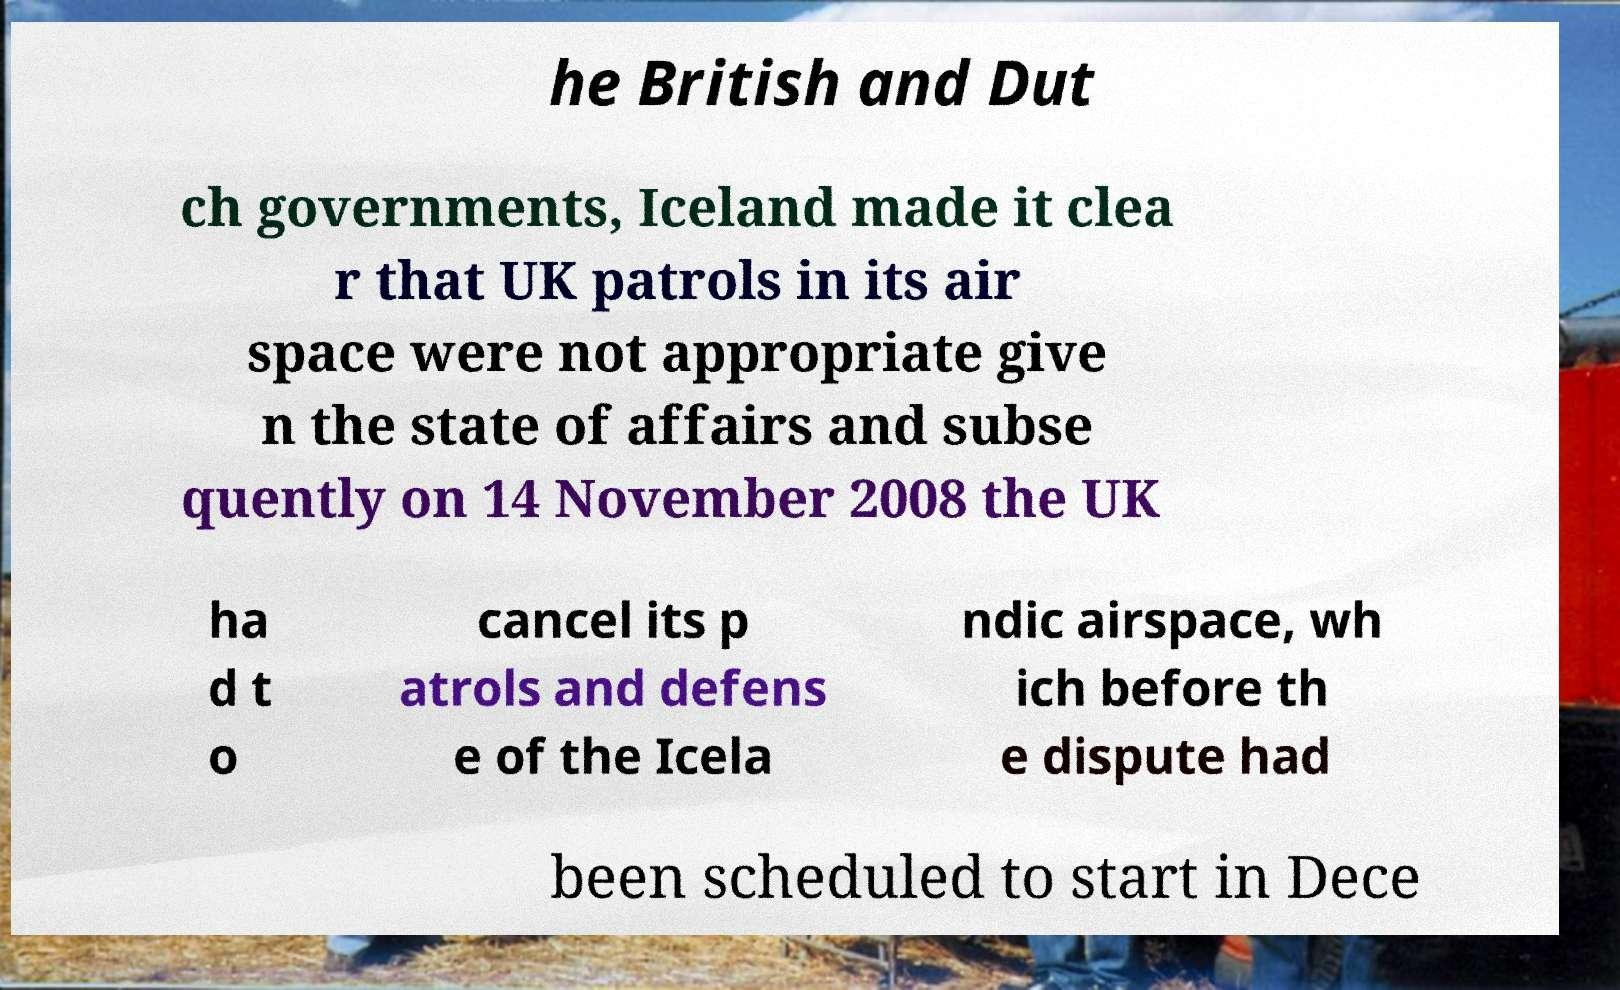Please read and relay the text visible in this image. What does it say? he British and Dut ch governments, Iceland made it clea r that UK patrols in its air space were not appropriate give n the state of affairs and subse quently on 14 November 2008 the UK ha d t o cancel its p atrols and defens e of the Icela ndic airspace, wh ich before th e dispute had been scheduled to start in Dece 